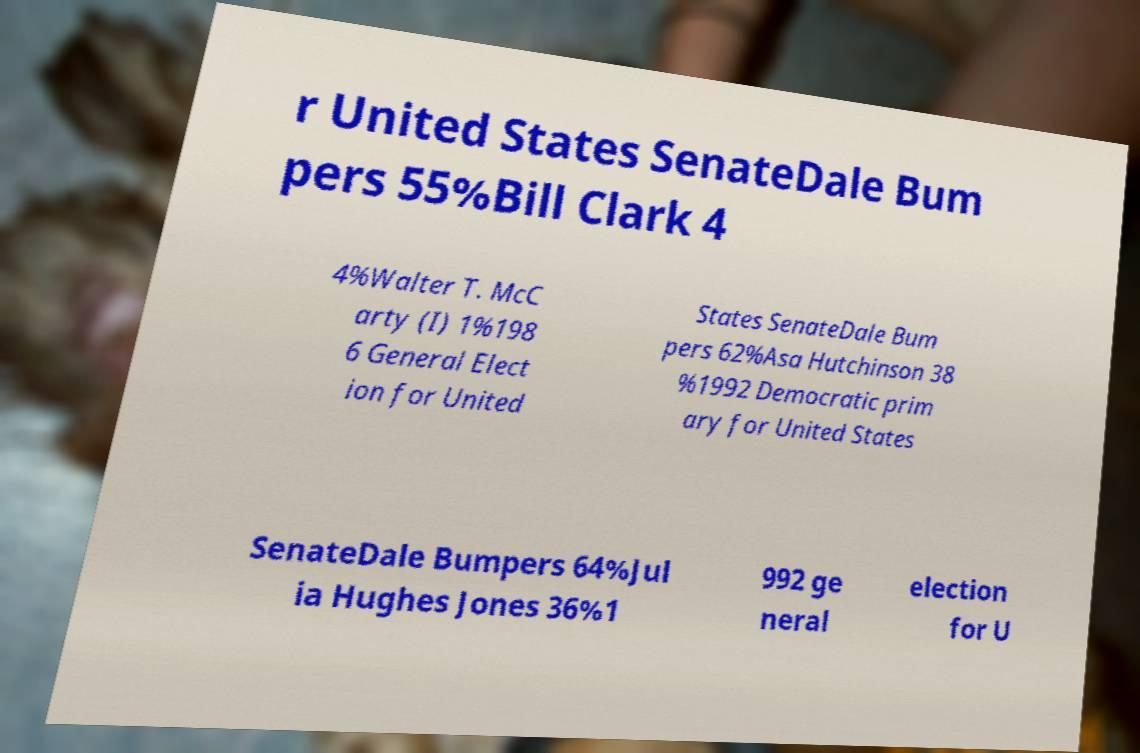Please identify and transcribe the text found in this image. r United States SenateDale Bum pers 55%Bill Clark 4 4%Walter T. McC arty (I) 1%198 6 General Elect ion for United States SenateDale Bum pers 62%Asa Hutchinson 38 %1992 Democratic prim ary for United States SenateDale Bumpers 64%Jul ia Hughes Jones 36%1 992 ge neral election for U 